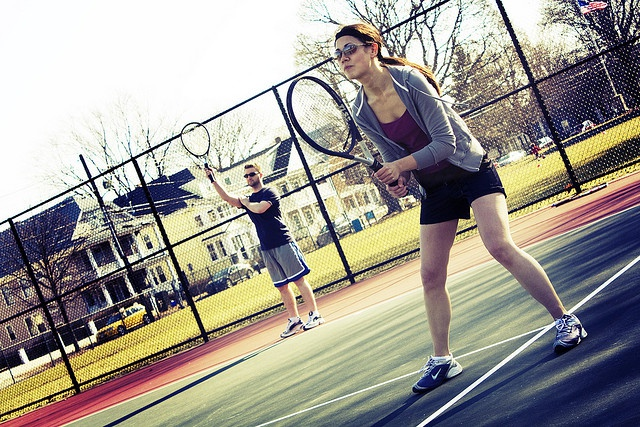Describe the objects in this image and their specific colors. I can see people in white, gray, black, and darkgray tones, people in white, navy, gray, and ivory tones, tennis racket in white, ivory, darkgray, and navy tones, car in white, black, khaki, navy, and olive tones, and tennis racket in white, ivory, black, beige, and darkgray tones in this image. 